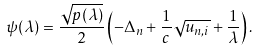Convert formula to latex. <formula><loc_0><loc_0><loc_500><loc_500>\psi ( \lambda ) = \frac { \sqrt { p ( \lambda ) } } { 2 } \left ( - \Delta _ { n } + \frac { 1 } { c } \sqrt { u _ { n , i } } + \frac { 1 } { \lambda } \right ) .</formula> 